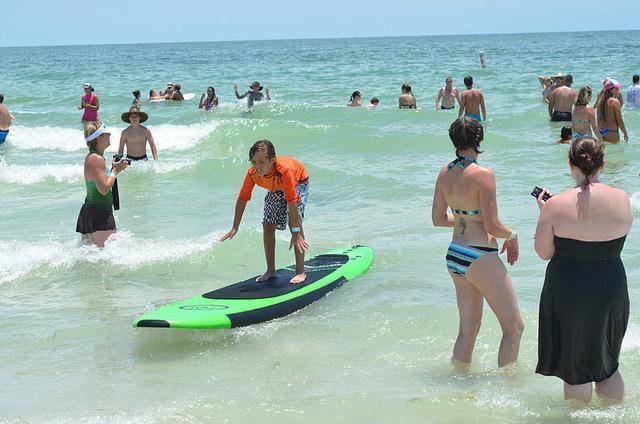How many surfboards are there?
Give a very brief answer. 1. How many people are there?
Give a very brief answer. 5. How many trains on the track?
Give a very brief answer. 0. 